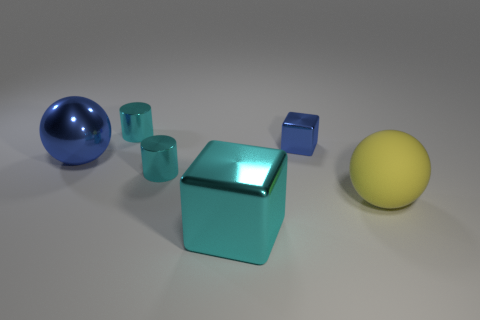What other colors are represented in the objects in the scene besides yellow and green? Along with the yellow rubber ball and the green rubber cubes, there's also a blue rubber ball and a cyan block present in the scene, adding a diverse range of colors to the composition. 